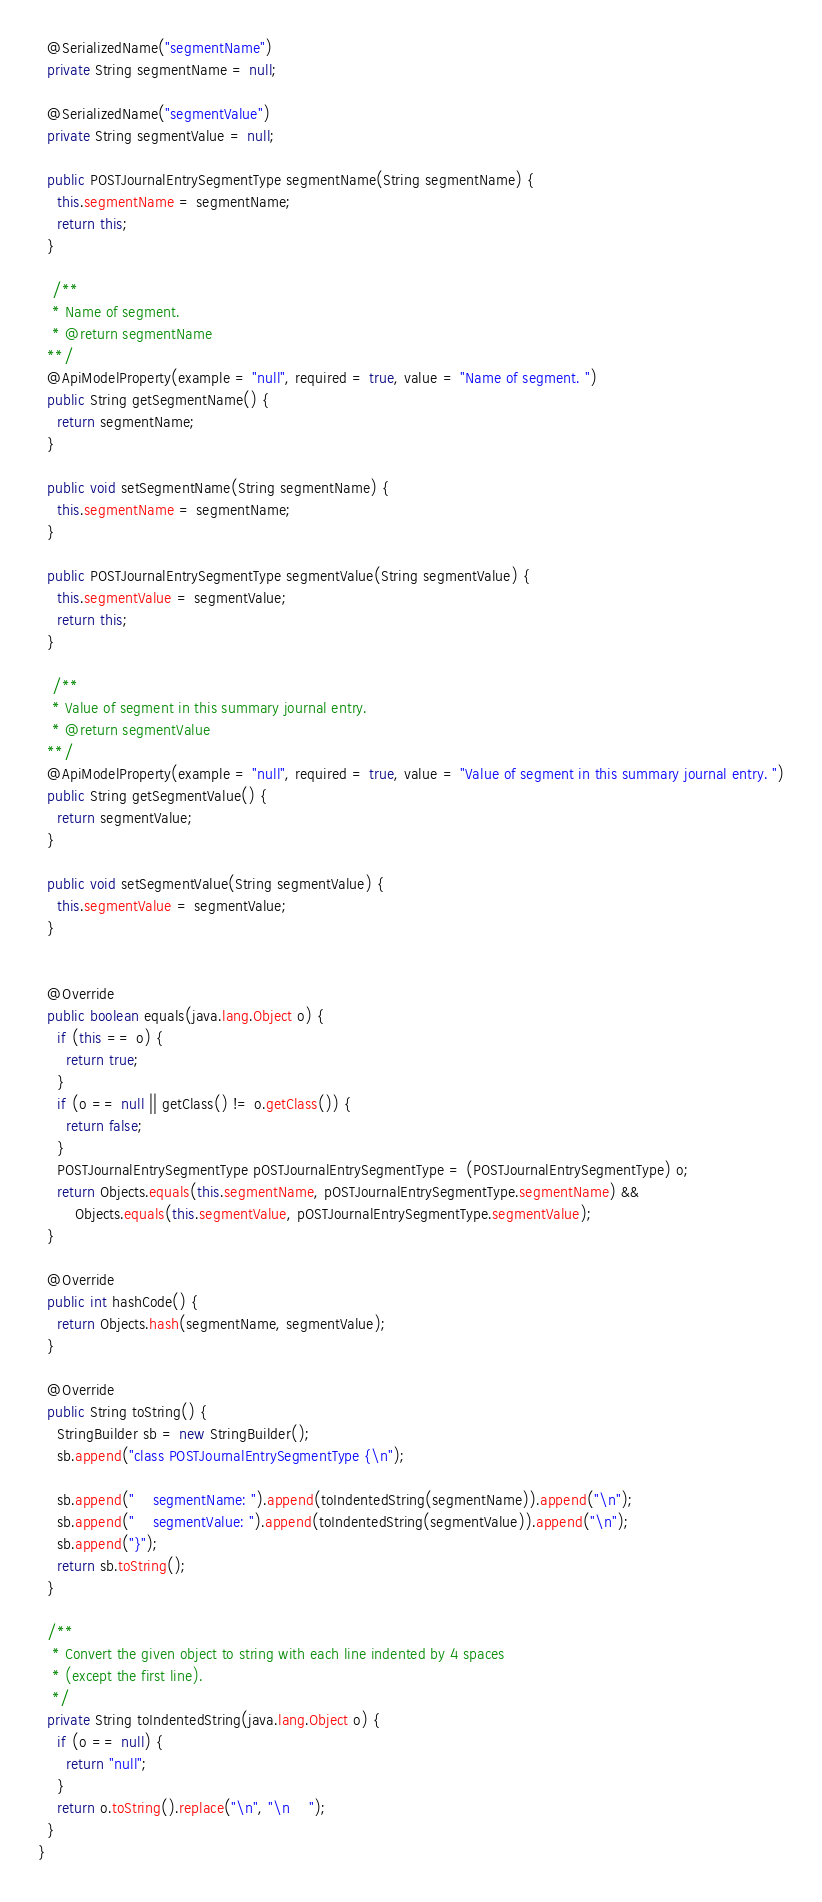<code> <loc_0><loc_0><loc_500><loc_500><_Java_>  @SerializedName("segmentName")
  private String segmentName = null;

  @SerializedName("segmentValue")
  private String segmentValue = null;

  public POSTJournalEntrySegmentType segmentName(String segmentName) {
    this.segmentName = segmentName;
    return this;
  }

   /**
   * Name of segment. 
   * @return segmentName
  **/
  @ApiModelProperty(example = "null", required = true, value = "Name of segment. ")
  public String getSegmentName() {
    return segmentName;
  }

  public void setSegmentName(String segmentName) {
    this.segmentName = segmentName;
  }

  public POSTJournalEntrySegmentType segmentValue(String segmentValue) {
    this.segmentValue = segmentValue;
    return this;
  }

   /**
   * Value of segment in this summary journal entry. 
   * @return segmentValue
  **/
  @ApiModelProperty(example = "null", required = true, value = "Value of segment in this summary journal entry. ")
  public String getSegmentValue() {
    return segmentValue;
  }

  public void setSegmentValue(String segmentValue) {
    this.segmentValue = segmentValue;
  }


  @Override
  public boolean equals(java.lang.Object o) {
    if (this == o) {
      return true;
    }
    if (o == null || getClass() != o.getClass()) {
      return false;
    }
    POSTJournalEntrySegmentType pOSTJournalEntrySegmentType = (POSTJournalEntrySegmentType) o;
    return Objects.equals(this.segmentName, pOSTJournalEntrySegmentType.segmentName) &&
        Objects.equals(this.segmentValue, pOSTJournalEntrySegmentType.segmentValue);
  }

  @Override
  public int hashCode() {
    return Objects.hash(segmentName, segmentValue);
  }

  @Override
  public String toString() {
    StringBuilder sb = new StringBuilder();
    sb.append("class POSTJournalEntrySegmentType {\n");
    
    sb.append("    segmentName: ").append(toIndentedString(segmentName)).append("\n");
    sb.append("    segmentValue: ").append(toIndentedString(segmentValue)).append("\n");
    sb.append("}");
    return sb.toString();
  }

  /**
   * Convert the given object to string with each line indented by 4 spaces
   * (except the first line).
   */
  private String toIndentedString(java.lang.Object o) {
    if (o == null) {
      return "null";
    }
    return o.toString().replace("\n", "\n    ");
  }
}

</code> 